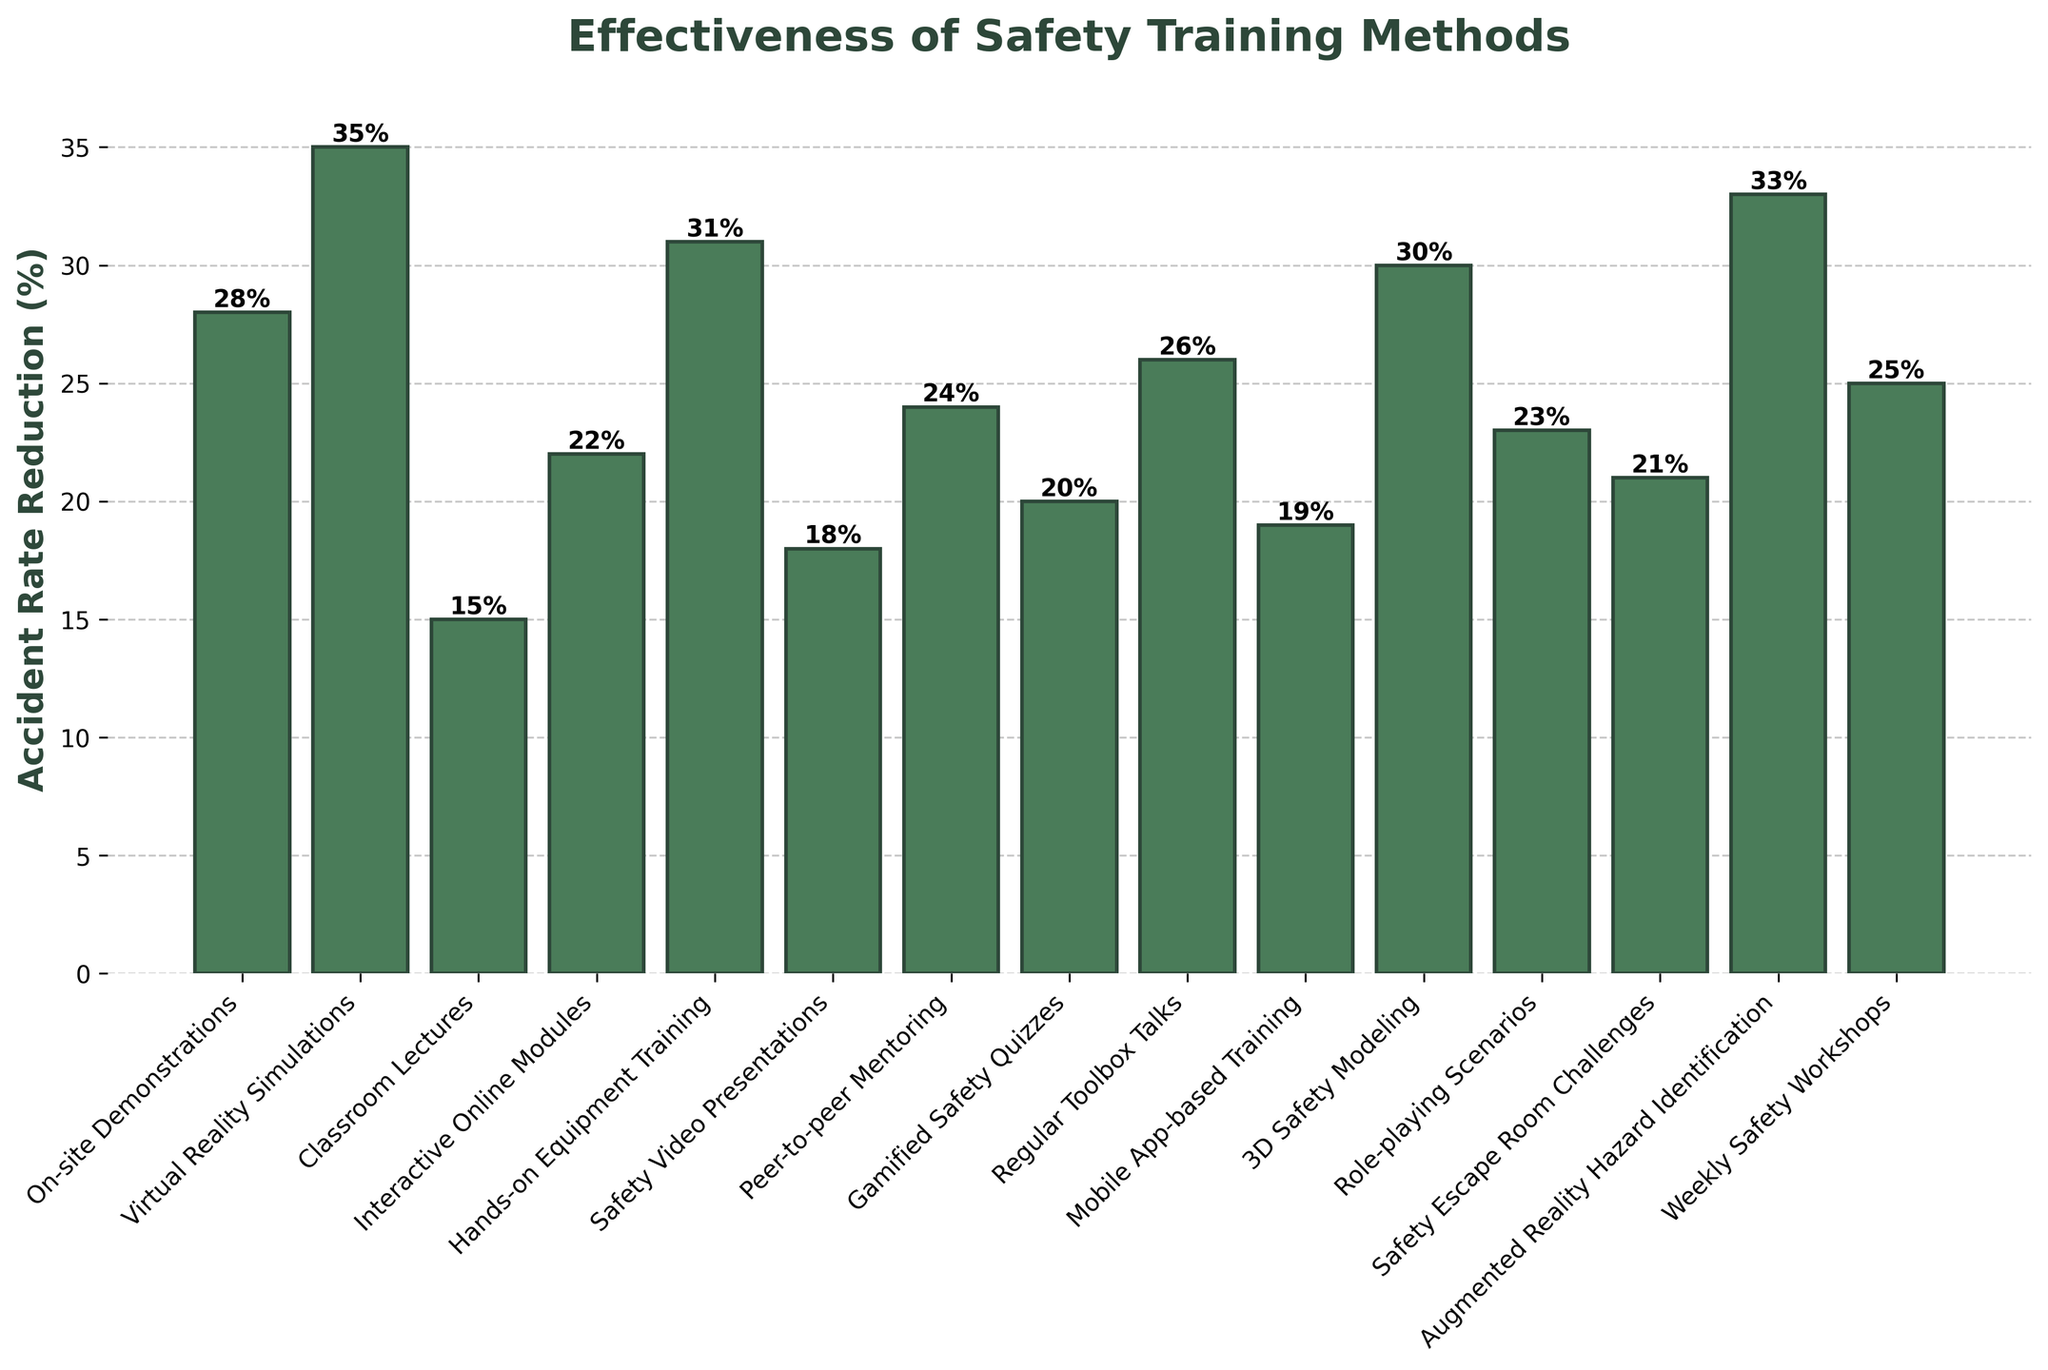what is the highest accident rate reduction in the figure? The highest accident rate reduction can be found by looking for the tallest bar in the figure. The "Virtual Reality Simulations" bar shows the highest reduction at 35%.
Answer: 35% Which training method has the lowest accident rate reduction? By looking for the shortest bar in the figure, we see that "Classroom Lectures" has the lowest accident rate reduction at 15%.
Answer: Classroom Lectures What is the sum of accident rate reductions for "On-site Demonstrations" and "Role-playing Scenarios"? Find the values of accident rate reductions for "On-site Demonstrations" (28%) and "Role-playing Scenarios" (23%), then add them together: 28% + 23% = 51%.
Answer: 51% How does the effectiveness of "Safety Video Presentations" compare to "Interactive Online Modules"? Check the heights of the bars corresponding to "Safety Video Presentations" and "Interactive Online Modules". "Safety Video Presentations" has a reduction of 18% while "Interactive Online Modules" has a reduction of 22%. Hence, "Interactive Online Modules" has a higher reduction.
Answer: Interactive Online Modules is higher What is the average accident rate reduction for "Gamified Safety Quizzes", "Safety Escape Room Challenges", and "Mobile App-based Training"? First, find the values of accident rate reduction for each method: "Gamified Safety Quizzes" (20%), "Safety Escape Room Challenges" (21%), and "Mobile App-based Training" (19%). Sum them up: 20% + 21% + 19% = 60%. Then, divide by the number of methods: 60% / 3 = 20%.
Answer: 20% Which method has a reduction percentage more than 30% but less than 35%? Look for bars that fall between the 30% and 35% range. "Hands-on Equipment Training" (31%), "3D Safety Modeling" (30%), and "Augmented Reality Hazard Identification" (33%) fit this criteria.
Answer: Hands-on Equipment Training, 3D Safety Modeling, Augmented Reality Hazard Identification How many training methods have a reduction rate of more than 25%? Count the bars that exceed the 25% mark. The methods are: "On-site Demonstrations" (28%), "Virtual Reality Simulations" (35%), "Hands-on Equipment Training" (31%), "3D Safety Modeling" (30%), "Augmented Reality Hazard Identification" (33%), and "Weekly Safety Workshops" (25%, equal to 25%). Therefore, there are 6 methods exceeding 25%.
Answer: 6 What is the difference in accident rate reduction between "Peer-to-peer Mentoring" and "Regular Toolbox Talks"? Determine the values for "Peer-to-peer Mentoring" (24%) and "Regular Toolbox Talks" (26%). Then, calculate the difference: 26% - 24% = 2%.
Answer: 2% 